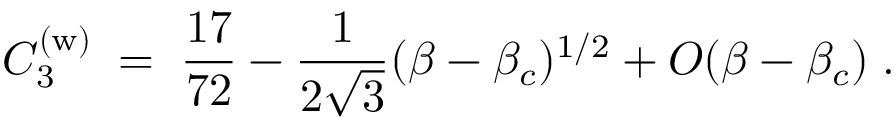<formula> <loc_0><loc_0><loc_500><loc_500>C _ { 3 } ^ { ( w ) } \, = \, { \frac { 1 7 } { 7 2 } } - { \frac { 1 } { 2 \sqrt { 3 } } } ( \beta - \beta _ { c } ) ^ { 1 / 2 } + O ( \beta - \beta _ { c } ) \, .</formula> 